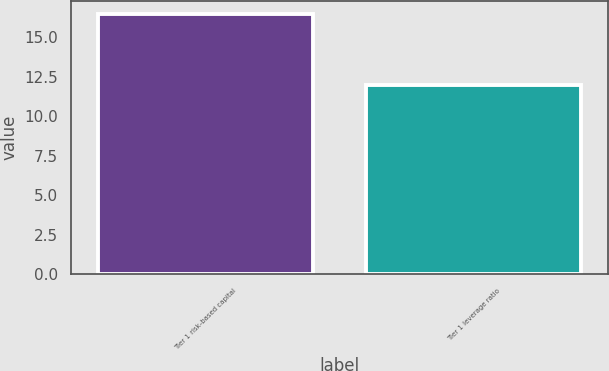<chart> <loc_0><loc_0><loc_500><loc_500><bar_chart><fcel>Tier 1 risk-based capital<fcel>Tier 1 leverage ratio<nl><fcel>16.5<fcel>12<nl></chart> 